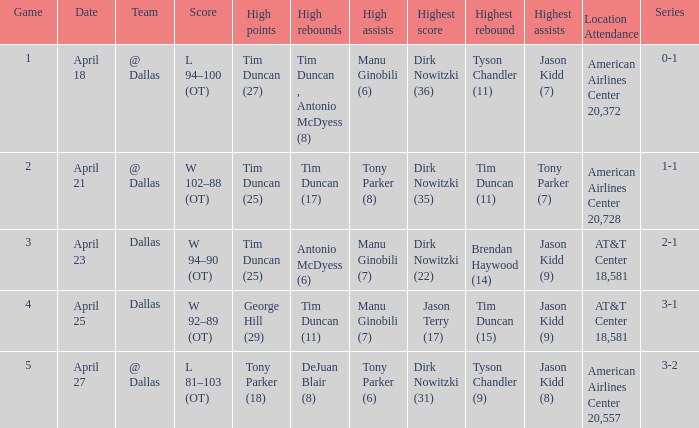When 5 is the game who has the highest amount of points? Tony Parker (18). 